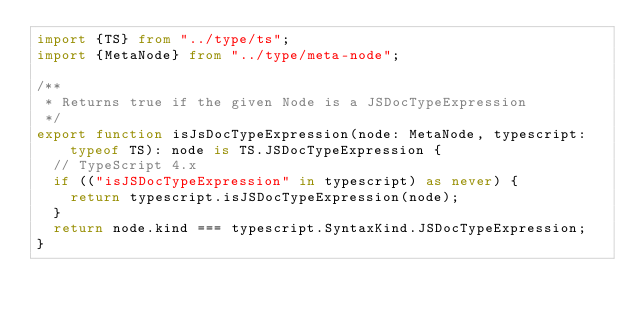<code> <loc_0><loc_0><loc_500><loc_500><_TypeScript_>import {TS} from "../type/ts";
import {MetaNode} from "../type/meta-node";

/**
 * Returns true if the given Node is a JSDocTypeExpression
 */
export function isJsDocTypeExpression(node: MetaNode, typescript: typeof TS): node is TS.JSDocTypeExpression {
	// TypeScript 4.x
	if (("isJSDocTypeExpression" in typescript) as never) {
		return typescript.isJSDocTypeExpression(node);
	}
	return node.kind === typescript.SyntaxKind.JSDocTypeExpression;
}
</code> 